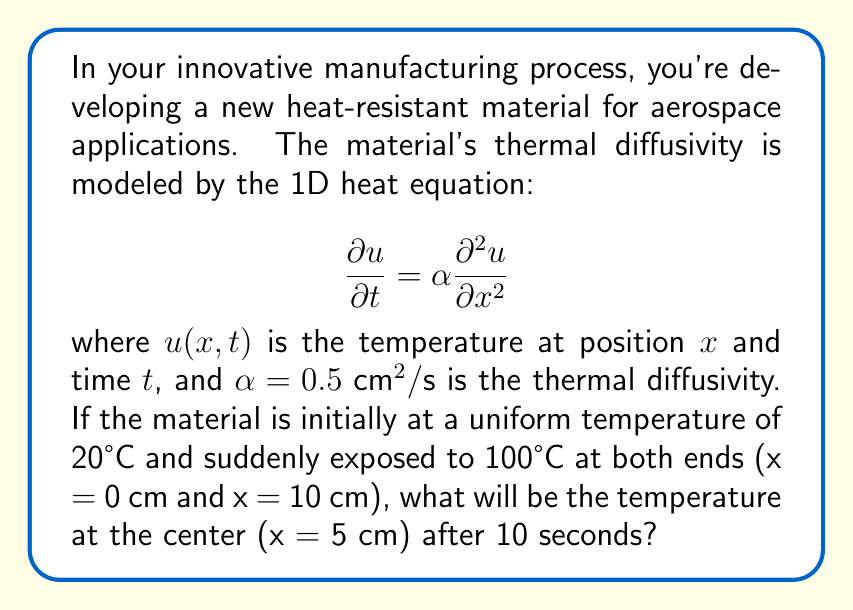Could you help me with this problem? To solve this problem, we'll use the analytical solution for the 1D heat equation with the given initial and boundary conditions. The solution is given by the Fourier series:

$$u(x,t) = 100 - 80 \sum_{n=1}^{\infty} \frac{1-(-1)^n}{n\pi} \sin\left(\frac{n\pi x}{L}\right) e^{-\alpha n^2\pi^2t/L^2}$$

where $L = 10 \text{ cm}$ is the length of the material.

Steps to calculate the temperature at x = 5 cm and t = 10 s:

1. Substitute the given values:
   $x = 5 \text{ cm}$
   $t = 10 \text{ s}$
   $\alpha = 0.5 \text{ cm}^2/\text{s}$
   $L = 10 \text{ cm}$

2. Calculate the first few terms of the series (n = 1, 3, 5, 7):

   For n = 1:
   $$\frac{1-(-1)^1}{1\pi} \sin\left(\frac{1\pi 5}{10}\right) e^{-0.5(1)^2\pi^2(10)/(10)^2} \approx 0.6366$$

   For n = 3:
   $$\frac{1-(-1)^3}{3\pi} \sin\left(\frac{3\pi 5}{10}\right) e^{-0.5(3)^2\pi^2(10)/(10)^2} \approx 0.0031$$

   For n = 5:
   $$\frac{1-(-1)^5}{5\pi} \sin\left(\frac{5\pi 5}{10}\right) e^{-0.5(5)^2\pi^2(10)/(10)^2} \approx 0$$

   For n = 7 and beyond, the terms become negligible.

3. Sum the calculated terms:
   $0.6366 + 0.0031 \approx 0.6397$

4. Multiply by -80 and add to 100:
   $100 - 80(0.6397) \approx 48.82°C$

Therefore, the temperature at the center of the material after 10 seconds will be approximately 48.82°C.
Answer: 48.82°C 